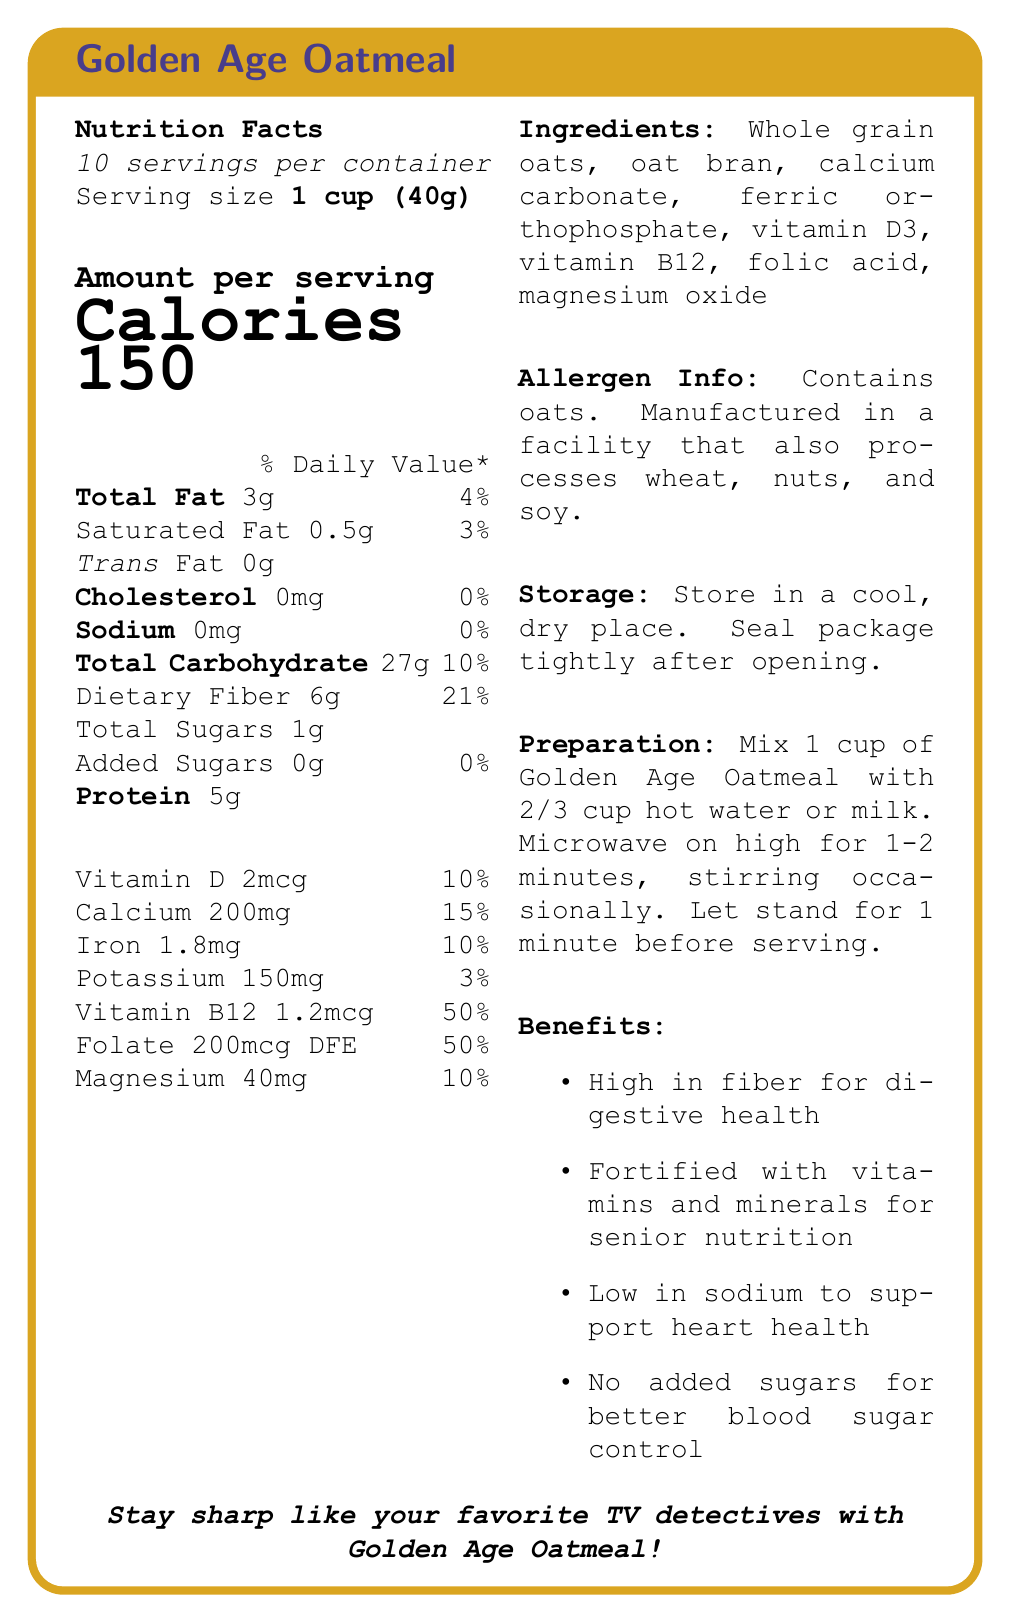What is the serving size for Golden Age Oatmeal? The serving size is listed at the beginning of the Nutrition Facts section as "1 cup (40g)."
Answer: 1 cup (40g) How much dietary fiber does each serving of Golden Age Oatmeal contain? The amount of dietary fiber is stated in the Nutrition Facts section with "Dietary Fiber 6g."
Answer: 6g What percentage of the daily value for vitamin B12 does one serving of this oatmeal provide? The percentage of the daily value for vitamin B12 is listed as 50% in the Nutrition Facts section.
Answer: 50% Does Golden Age Oatmeal contain any trans fat? The Nutrition Facts section clearly states "Trans Fat 0g."
Answer: No How many servings are there in one container of Golden Age Oatmeal? The document states "10 servings per container" at the beginning of the Nutrition Facts section.
Answer: 10 Which of the following vitamins and minerals have the highest daily value percentage in this oatmeal? A. Vitamin D B. Folic acid C. Iron D. Calcium The daily values are as follows: Vitamin D - 10%, Folic acid - 50%, Iron - 10%, Calcium - 15%. Folic acid has the highest daily value at 50%.
Answer: B How many grams of total fat are in one serving of Golden Age Oatmeal? A. 2g B. 3g C. 4g D. 5g The Nutrition Facts section lists "Total Fat 3g," so the correct answer is 3g.
Answer: B Is Golden Age Oatmeal suitable for someone who is avoiding added sugars? The Nutrition Facts section shows "Added Sugars 0g," indicating there are no added sugars.
Answer: Yes Summarize the main idea of the Golden Age Oatmeal document. This conclusion is drawn from the product benefits and description sections, which highlight its focus on senior nutrition, high fiber content, and low sodium.
Answer: Golden Age Oatmeal is a high-fiber breakfast option designed specifically for active seniors. It is fortified with vitamins and minerals, supports heart health with low sodium, and contains no added sugars for better blood sugar control. What is the main ingredient of Golden Age Oatmeal? The first and prominently listed ingredient in the ingredients section is "Whole grain oats."
Answer: Whole grain oats How much iron is in one serving of Golden Age Oatmeal? The Nutrition Facts section lists "Iron 1.8mg."
Answer: 1.8mg What can you say about the allergen information for Golden Age Oatmeal? A. It contains nuts B. It contains soy C. It contains oats D. It contains wheat The allergen info clearly states that the product contains oats, but doesn't contain nuts, soy, or wheat directly.
Answer: C What is the caloric content per serving of Golden Age Oatmeal? The calories per serving are prominently displayed in the Nutrition Facts section as "Calories 150."
Answer: 150 calories Does the document provide enough information about the manufacturer's contact details? The document does not include any details about the manufacturer's contact information.
Answer: Not enough information 